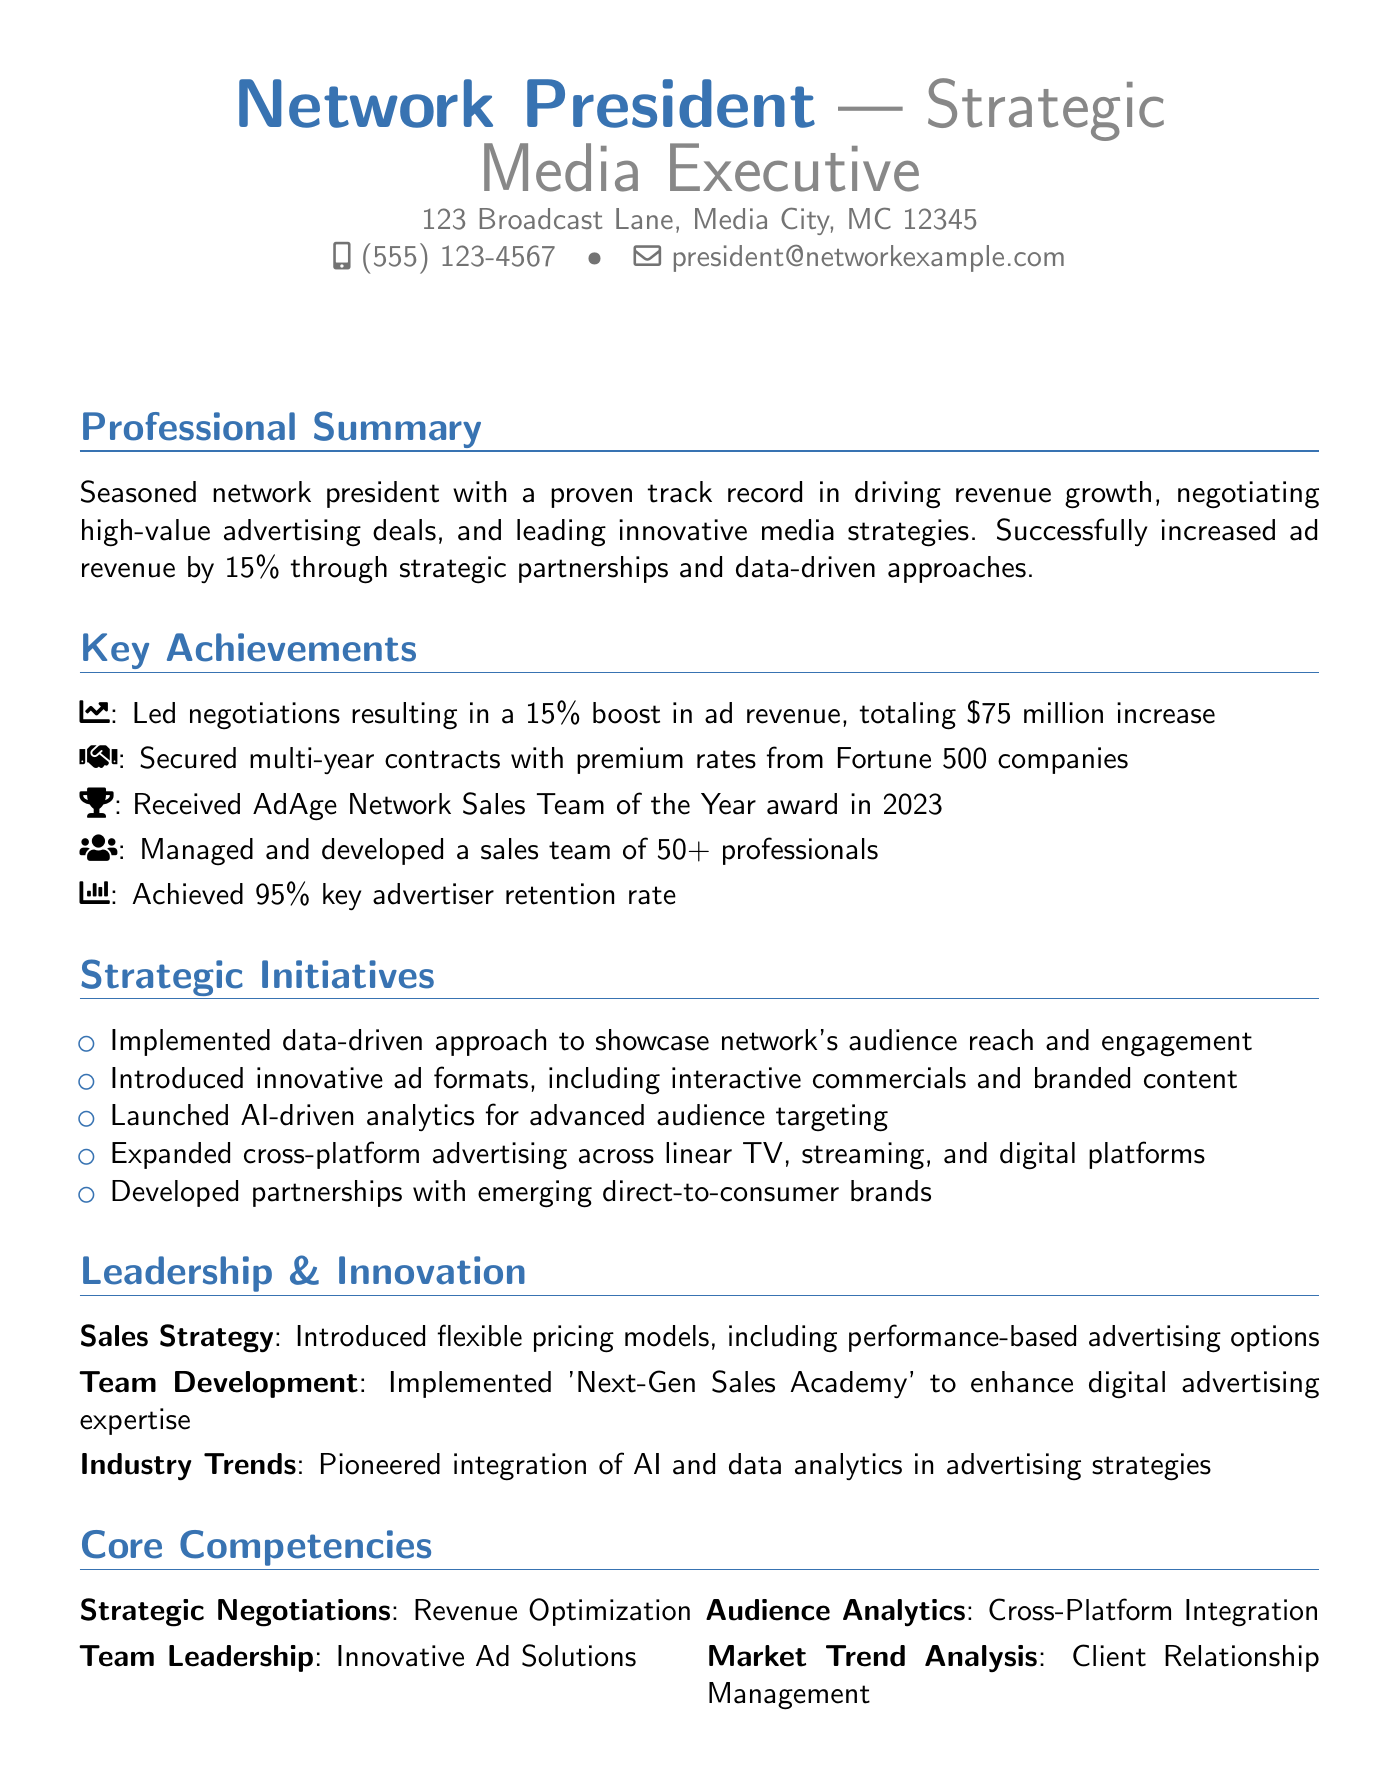what was the percentage boost in ad revenue? The document states a 15% boost in ad revenue resulting from successful negotiations.
Answer: 15% who were some of the companies involved in the negotiations? The executive summary lists Procter & Gamble, Coca-Cola, and Ford Motor Company as key advertisers involved in the negotiations.
Answer: Procter & Gamble, Coca-Cola, Ford Motor Company what is the total increase in revenue? The document mentions that the negotiations resulted in a $75 million increase in revenue.
Answer: $75 million what award did the network receive in 2023? The award highlighted in the document is AdAge Network Sales Team of the Year for the year 2023.
Answer: AdAge Network Sales Team of the Year how many professionals are on the sales team? The document states that the sales team comprises more than 50 professionals.
Answer: 50+ what retention rate was achieved for key advertisers? The document specifies a key advertiser retention rate of 95%.
Answer: 95% what innovative ad formats were introduced? The document mentions interactive commercials and branded content integrations as innovative ad formats introduced during negotiations.
Answer: interactive commercials and branded content what training program was implemented for the sales team? The document specifies the 'Next-Gen Sales Academy' as the training program introduced to enhance the team's expertise.
Answer: Next-Gen Sales Academy what strategic approach was used in negotiations? The document notes a data-driven approach utilized to show the network's audience reach and engagement metrics during negotiations.
Answer: data-driven approach 